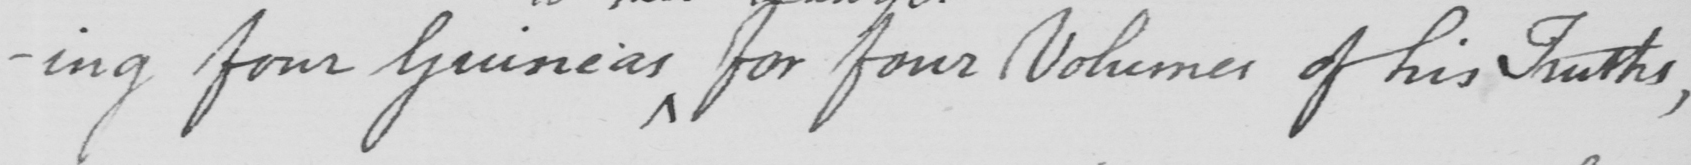What text is written in this handwritten line? ing four Guineas for four Volumes of his Truths, 